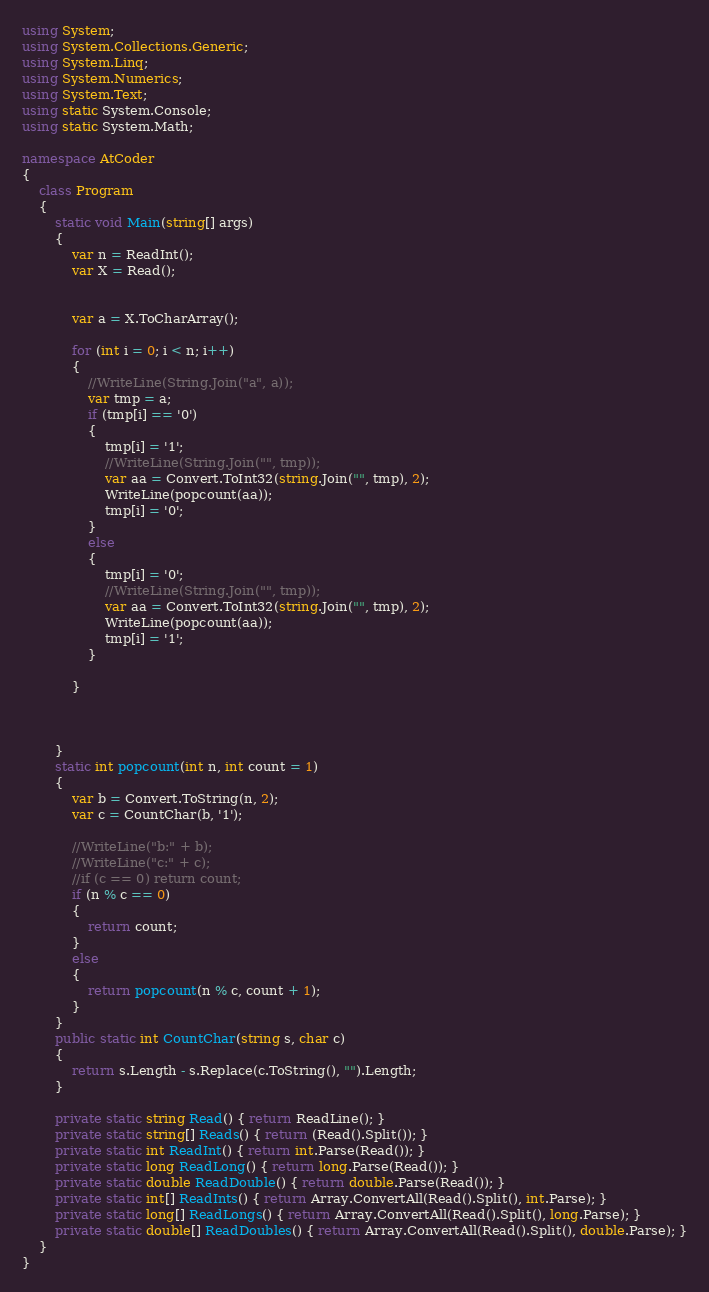<code> <loc_0><loc_0><loc_500><loc_500><_C#_>using System;
using System.Collections.Generic;
using System.Linq;
using System.Numerics;
using System.Text;
using static System.Console;
using static System.Math;

namespace AtCoder
{
    class Program
    {
        static void Main(string[] args)
        {
            var n = ReadInt();
            var X = Read();


            var a = X.ToCharArray();

            for (int i = 0; i < n; i++)
            {
                //WriteLine(String.Join("a", a));
                var tmp = a;
                if (tmp[i] == '0')
                {
                    tmp[i] = '1';
                    //WriteLine(String.Join("", tmp));
                    var aa = Convert.ToInt32(string.Join("", tmp), 2);
                    WriteLine(popcount(aa));
                    tmp[i] = '0';
                }
                else
                {
                    tmp[i] = '0';
                    //WriteLine(String.Join("", tmp));
                    var aa = Convert.ToInt32(string.Join("", tmp), 2);
                    WriteLine(popcount(aa));
                    tmp[i] = '1';
                }

            }



        }
        static int popcount(int n, int count = 1)
        {
            var b = Convert.ToString(n, 2);
            var c = CountChar(b, '1');

            //WriteLine("b:" + b);
            //WriteLine("c:" + c);
            //if (c == 0) return count;
            if (n % c == 0)
            {
                return count;
            }
            else
            {
                return popcount(n % c, count + 1);
            }
        }
        public static int CountChar(string s, char c)
        {
            return s.Length - s.Replace(c.ToString(), "").Length;
        }

        private static string Read() { return ReadLine(); }
        private static string[] Reads() { return (Read().Split()); }
        private static int ReadInt() { return int.Parse(Read()); }
        private static long ReadLong() { return long.Parse(Read()); }
        private static double ReadDouble() { return double.Parse(Read()); }
        private static int[] ReadInts() { return Array.ConvertAll(Read().Split(), int.Parse); }
        private static long[] ReadLongs() { return Array.ConvertAll(Read().Split(), long.Parse); }
        private static double[] ReadDoubles() { return Array.ConvertAll(Read().Split(), double.Parse); }
    }
}
</code> 